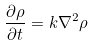<formula> <loc_0><loc_0><loc_500><loc_500>\frac { \partial \rho } { \partial t } = k \nabla ^ { 2 } \rho</formula> 